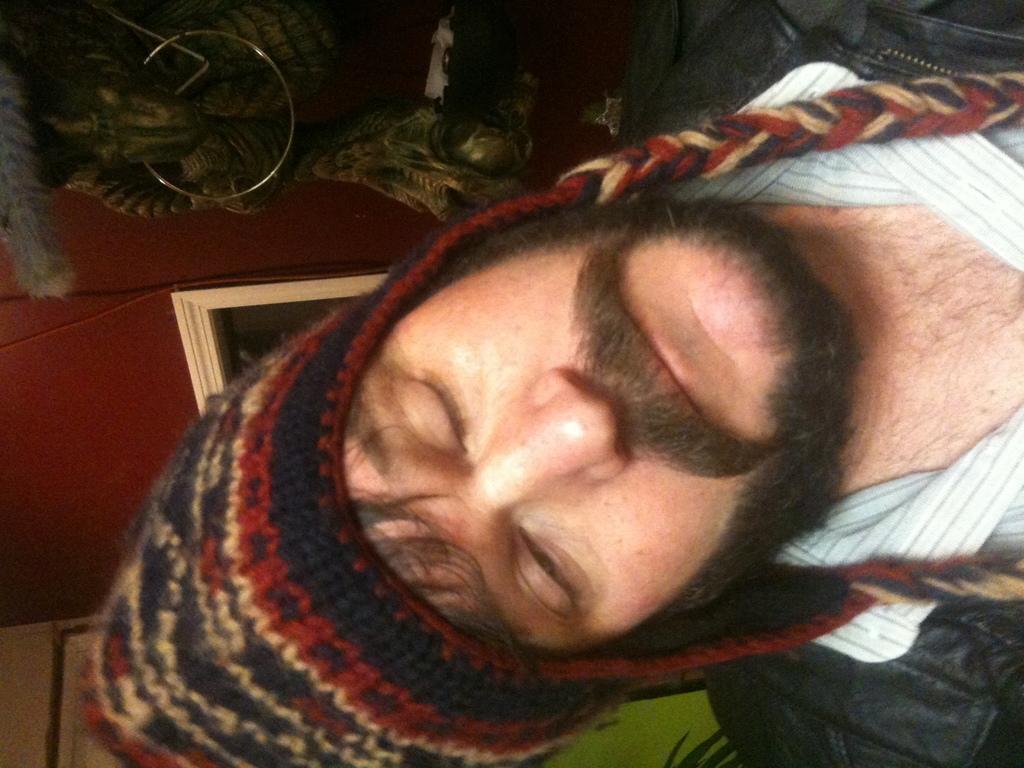In one or two sentences, can you explain what this image depicts? In this image there is one person on the right side of this image and there is a wall on the left side of this image. There is one object on the top of this image. 